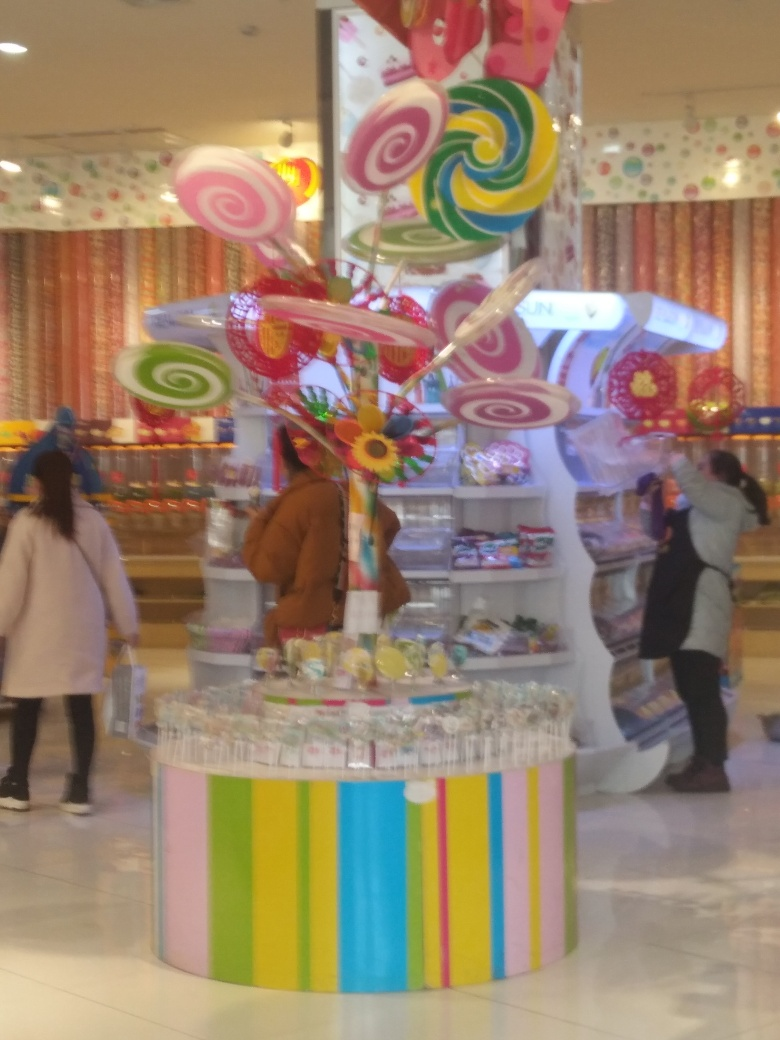What kind of place is shown in the image? The image displays a candy shop with a whimsical presentation, featuring a colorful arrangement of sweets and large decorative lollipops that create a playful and inviting atmosphere. What can you tell about the mood of the place? The mood seems to be joyous and lively, enhanced by the bright colors and fanciful decorations which are often associated with celebration and happiness. 